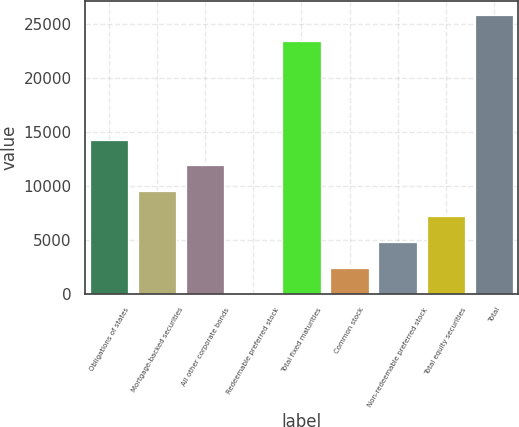Convert chart to OTSL. <chart><loc_0><loc_0><loc_500><loc_500><bar_chart><fcel>Obligations of states<fcel>Mortgage-backed securities<fcel>All other corporate bonds<fcel>Redeemable preferred stock<fcel>Total fixed maturities<fcel>Common stock<fcel>Non-redeemable preferred stock<fcel>Total equity securities<fcel>Total<nl><fcel>14227.6<fcel>9499.4<fcel>11863.5<fcel>43<fcel>23427<fcel>2407.1<fcel>4771.2<fcel>7135.3<fcel>25791.1<nl></chart> 